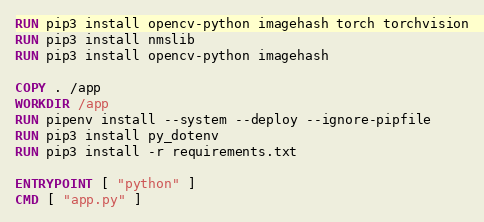Convert code to text. <code><loc_0><loc_0><loc_500><loc_500><_Dockerfile_>RUN pip3 install opencv-python imagehash torch torchvision
RUN pip3 install nmslib
RUN pip3 install opencv-python imagehash

COPY . /app
WORKDIR /app
RUN pipenv install --system --deploy --ignore-pipfile
RUN pip3 install py_dotenv
RUN pip3 install -r requirements.txt

ENTRYPOINT [ "python" ]
CMD [ "app.py" ]
</code> 